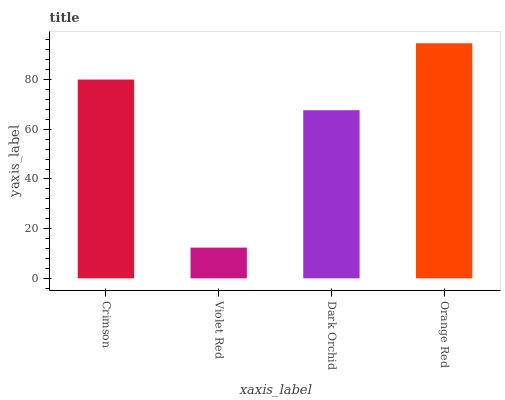Is Violet Red the minimum?
Answer yes or no. Yes. Is Orange Red the maximum?
Answer yes or no. Yes. Is Dark Orchid the minimum?
Answer yes or no. No. Is Dark Orchid the maximum?
Answer yes or no. No. Is Dark Orchid greater than Violet Red?
Answer yes or no. Yes. Is Violet Red less than Dark Orchid?
Answer yes or no. Yes. Is Violet Red greater than Dark Orchid?
Answer yes or no. No. Is Dark Orchid less than Violet Red?
Answer yes or no. No. Is Crimson the high median?
Answer yes or no. Yes. Is Dark Orchid the low median?
Answer yes or no. Yes. Is Violet Red the high median?
Answer yes or no. No. Is Violet Red the low median?
Answer yes or no. No. 